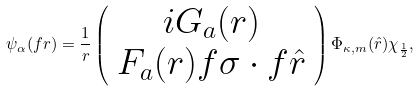Convert formula to latex. <formula><loc_0><loc_0><loc_500><loc_500>\psi _ { \alpha } ( { f { r } } ) = \frac { 1 } { r } \left ( \begin{array} { c } i G _ { a } ( r ) \\ F _ { a } ( r ) { f { \sigma } } \cdot { f { \hat { r } } } \end{array} \right ) \Phi _ { \kappa , m } ( \hat { r } ) \chi _ { \frac { 1 } { 2 } } ,</formula> 